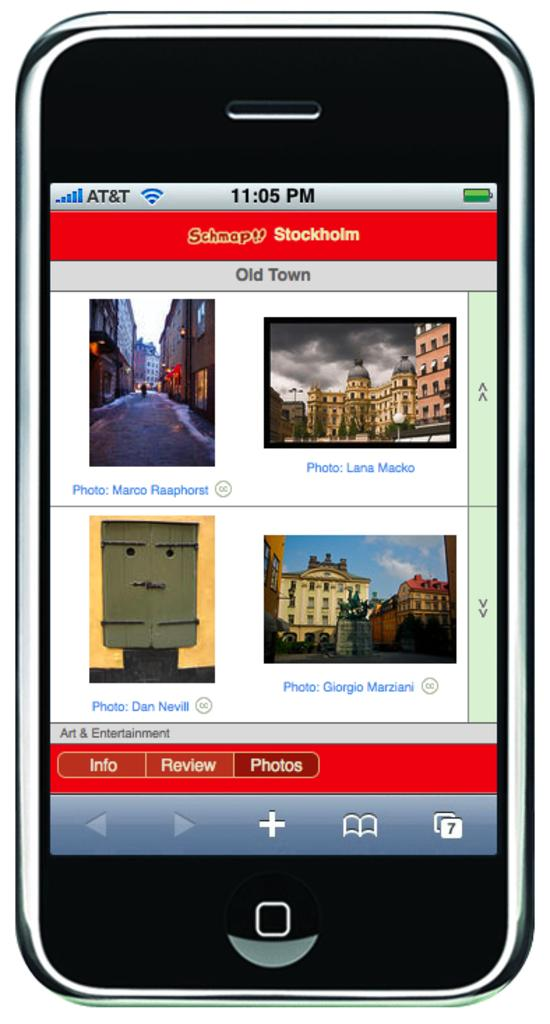<image>
Present a compact description of the photo's key features. an iphone with the screen on and time reading 11:05 pm 